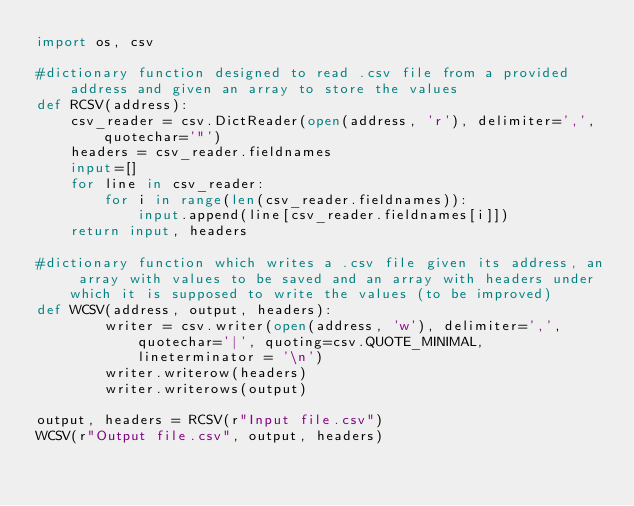<code> <loc_0><loc_0><loc_500><loc_500><_Python_>import os, csv

#dictionary function designed to read .csv file from a provided address and given an array to store the values			
def RCSV(address):
	csv_reader = csv.DictReader(open(address, 'r'), delimiter=',', quotechar='"')
	headers = csv_reader.fieldnames
	input=[]
	for line in csv_reader:
		for i in range(len(csv_reader.fieldnames)):
			input.append(line[csv_reader.fieldnames[i]])
	return input, headers

#dictionary function which writes a .csv file given its address, an array with values to be saved and an array with headers under which it is supposed to write the values (to be improved)
def WCSV(address, output, headers):
		writer = csv.writer(open(address, 'w'), delimiter=',', quotechar='|', quoting=csv.QUOTE_MINIMAL, lineterminator = '\n')
		writer.writerow(headers)
		writer.writerows(output)	
		
output, headers = RCSV(r"Input file.csv")
WCSV(r"Output file.csv", output, headers)</code> 